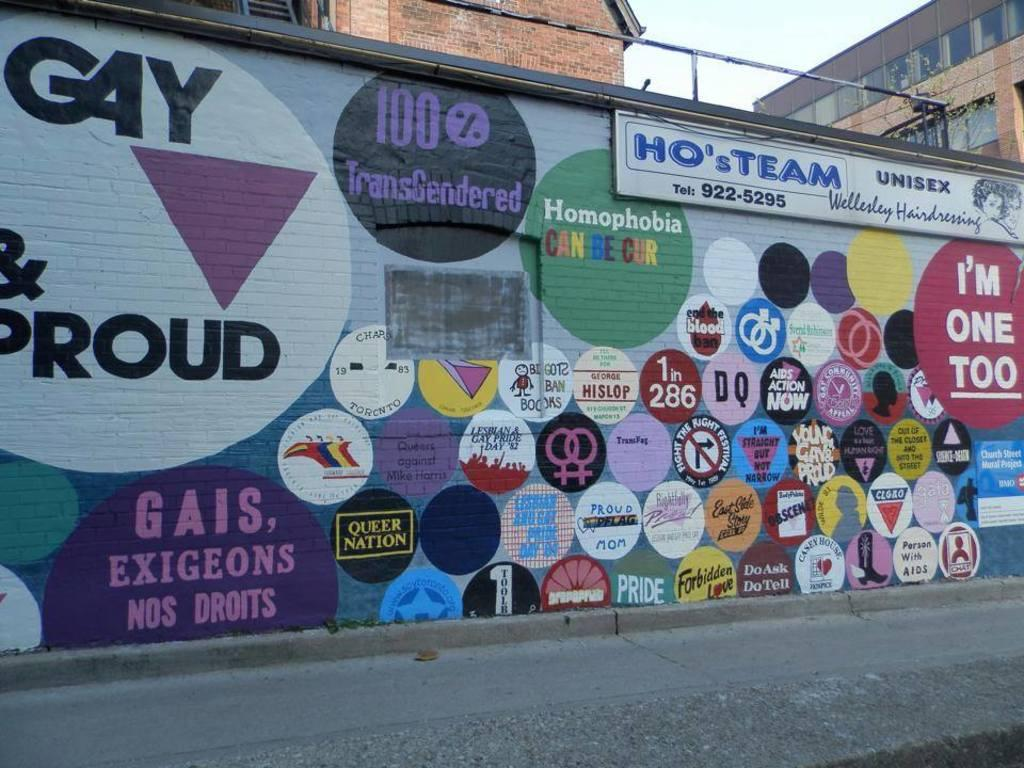<image>
Offer a succinct explanation of the picture presented. The side of a building with colorful circles on it and a large Gay and Proud circle. 